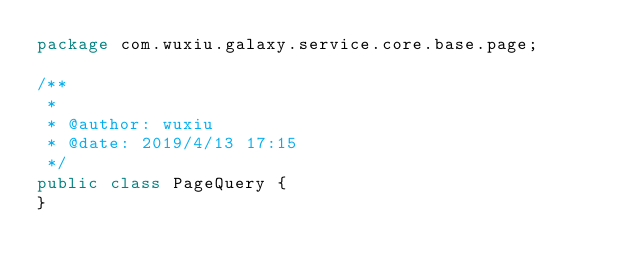<code> <loc_0><loc_0><loc_500><loc_500><_Java_>package com.wuxiu.galaxy.service.core.base.page;

/**
 *
 * @author: wuxiu
 * @date: 2019/4/13 17:15
 */
public class PageQuery {
}
</code> 